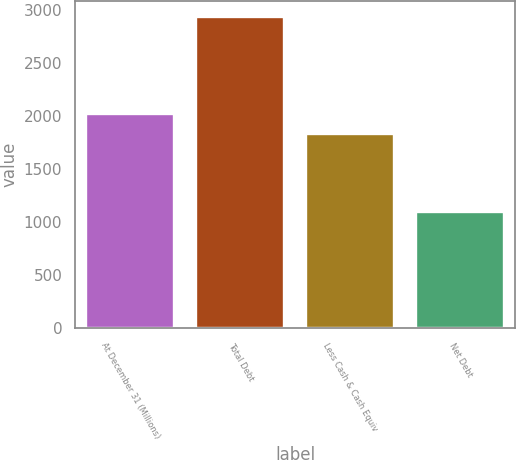<chart> <loc_0><loc_0><loc_500><loc_500><bar_chart><fcel>At December 31 (Millions)<fcel>Total Debt<fcel>Less Cash & Cash Equiv<fcel>Net Debt<nl><fcel>2019.6<fcel>2937<fcel>1836<fcel>1101<nl></chart> 